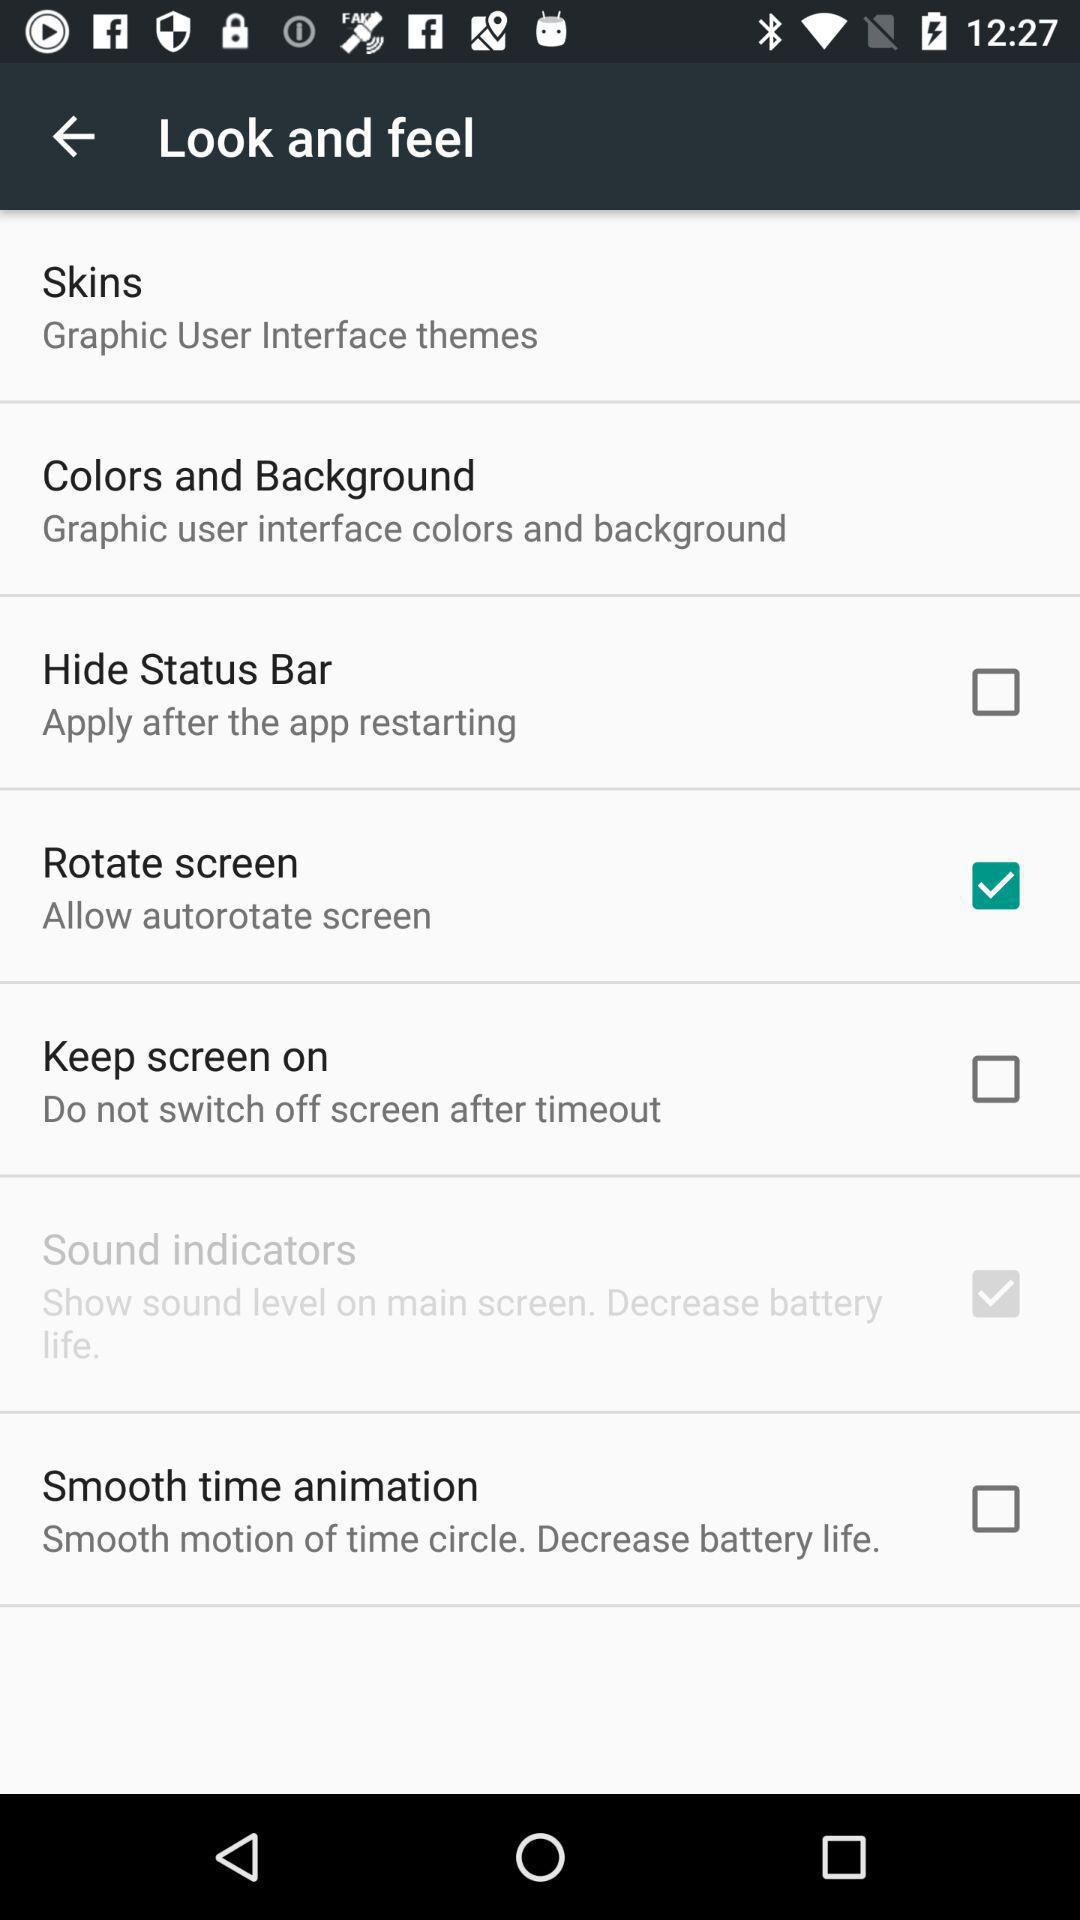What option is checked? The checked options are "Rotate screen" and "Sound indicators". 